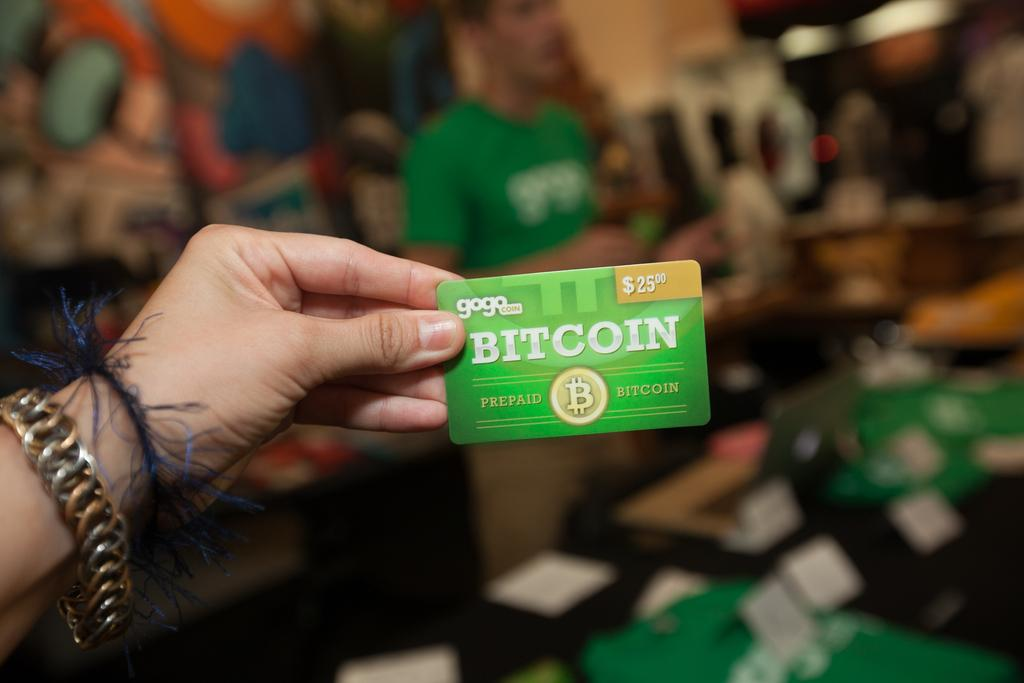What is the main subject of the image? There is a person in the image. What is the person holding in the image? The person is holding a card. Can you describe the background of the image? The background of the image is blurred. What type of expansion can be seen in the image? There is no expansion visible in the image; it features a person holding a card with a blurred background. 